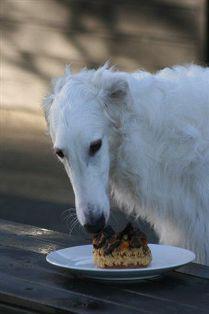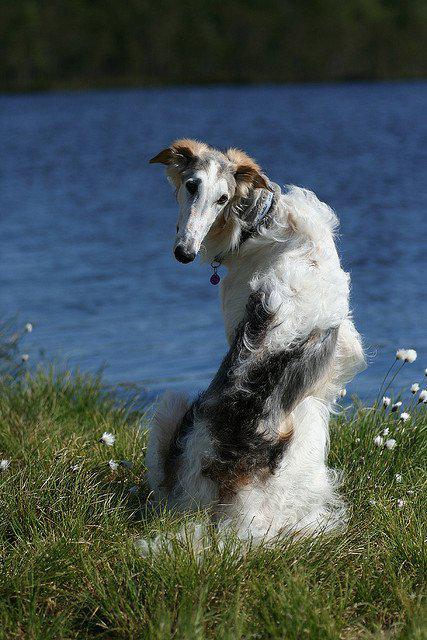The first image is the image on the left, the second image is the image on the right. For the images displayed, is the sentence "The right image contains two dogs." factually correct? Answer yes or no. No. 